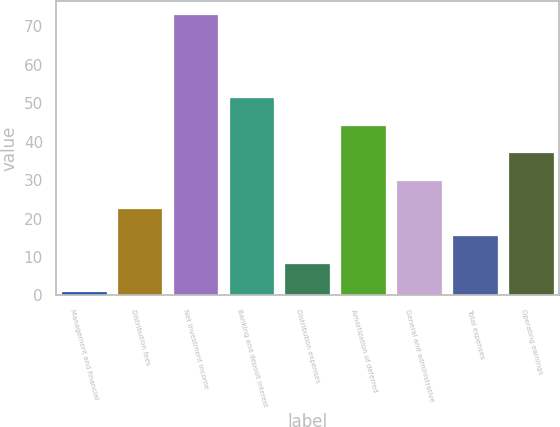Convert chart to OTSL. <chart><loc_0><loc_0><loc_500><loc_500><bar_chart><fcel>Management and financial<fcel>Distribution fees<fcel>Net investment income<fcel>Banking and deposit interest<fcel>Distribution expenses<fcel>Amortization of deferred<fcel>General and administrative<fcel>Total expenses<fcel>Operating earnings<nl><fcel>1<fcel>22.6<fcel>73<fcel>51.4<fcel>8.2<fcel>44.2<fcel>29.8<fcel>15.4<fcel>37<nl></chart> 